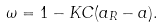<formula> <loc_0><loc_0><loc_500><loc_500>\omega = 1 - K C ( a _ { R } - a ) .</formula> 